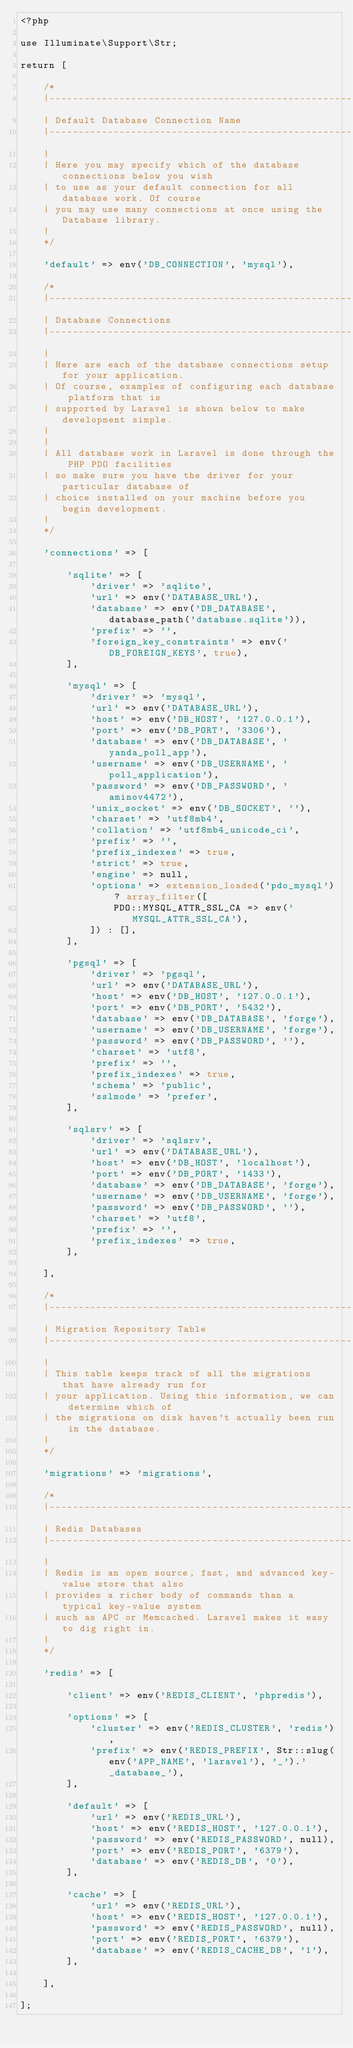Convert code to text. <code><loc_0><loc_0><loc_500><loc_500><_PHP_><?php

use Illuminate\Support\Str;

return [

    /*
    |--------------------------------------------------------------------------
    | Default Database Connection Name
    |--------------------------------------------------------------------------
    |
    | Here you may specify which of the database connections below you wish
    | to use as your default connection for all database work. Of course
    | you may use many connections at once using the Database library.
    |
    */

    'default' => env('DB_CONNECTION', 'mysql'),

    /*
    |--------------------------------------------------------------------------
    | Database Connections
    |--------------------------------------------------------------------------
    |
    | Here are each of the database connections setup for your application.
    | Of course, examples of configuring each database platform that is
    | supported by Laravel is shown below to make development simple.
    |
    |
    | All database work in Laravel is done through the PHP PDO facilities
    | so make sure you have the driver for your particular database of
    | choice installed on your machine before you begin development.
    |
    */

    'connections' => [

        'sqlite' => [
            'driver' => 'sqlite',
            'url' => env('DATABASE_URL'),
            'database' => env('DB_DATABASE', database_path('database.sqlite')),
            'prefix' => '',
            'foreign_key_constraints' => env('DB_FOREIGN_KEYS', true),
        ],

        'mysql' => [
            'driver' => 'mysql',
            'url' => env('DATABASE_URL'),
            'host' => env('DB_HOST', '127.0.0.1'),
            'port' => env('DB_PORT', '3306'),
            'database' => env('DB_DATABASE', 'yanda_poll_app'),
            'username' => env('DB_USERNAME', 'poll_application'),
            'password' => env('DB_PASSWORD', 'aminov4472'),
            'unix_socket' => env('DB_SOCKET', ''),
            'charset' => 'utf8mb4',
            'collation' => 'utf8mb4_unicode_ci',
            'prefix' => '',
            'prefix_indexes' => true,
            'strict' => true,
            'engine' => null,
            'options' => extension_loaded('pdo_mysql') ? array_filter([
                PDO::MYSQL_ATTR_SSL_CA => env('MYSQL_ATTR_SSL_CA'),
            ]) : [],
        ],

        'pgsql' => [
            'driver' => 'pgsql',
            'url' => env('DATABASE_URL'),
            'host' => env('DB_HOST', '127.0.0.1'),
            'port' => env('DB_PORT', '5432'),
            'database' => env('DB_DATABASE', 'forge'),
            'username' => env('DB_USERNAME', 'forge'),
            'password' => env('DB_PASSWORD', ''),
            'charset' => 'utf8',
            'prefix' => '',
            'prefix_indexes' => true,
            'schema' => 'public',
            'sslmode' => 'prefer',
        ],

        'sqlsrv' => [
            'driver' => 'sqlsrv',
            'url' => env('DATABASE_URL'),
            'host' => env('DB_HOST', 'localhost'),
            'port' => env('DB_PORT', '1433'),
            'database' => env('DB_DATABASE', 'forge'),
            'username' => env('DB_USERNAME', 'forge'),
            'password' => env('DB_PASSWORD', ''),
            'charset' => 'utf8',
            'prefix' => '',
            'prefix_indexes' => true,
        ],

    ],

    /*
    |--------------------------------------------------------------------------
    | Migration Repository Table
    |--------------------------------------------------------------------------
    |
    | This table keeps track of all the migrations that have already run for
    | your application. Using this information, we can determine which of
    | the migrations on disk haven't actually been run in the database.
    |
    */

    'migrations' => 'migrations',

    /*
    |--------------------------------------------------------------------------
    | Redis Databases
    |--------------------------------------------------------------------------
    |
    | Redis is an open source, fast, and advanced key-value store that also
    | provides a richer body of commands than a typical key-value system
    | such as APC or Memcached. Laravel makes it easy to dig right in.
    |
    */

    'redis' => [

        'client' => env('REDIS_CLIENT', 'phpredis'),

        'options' => [
            'cluster' => env('REDIS_CLUSTER', 'redis'),
            'prefix' => env('REDIS_PREFIX', Str::slug(env('APP_NAME', 'laravel'), '_').'_database_'),
        ],

        'default' => [
            'url' => env('REDIS_URL'),
            'host' => env('REDIS_HOST', '127.0.0.1'),
            'password' => env('REDIS_PASSWORD', null),
            'port' => env('REDIS_PORT', '6379'),
            'database' => env('REDIS_DB', '0'),
        ],

        'cache' => [
            'url' => env('REDIS_URL'),
            'host' => env('REDIS_HOST', '127.0.0.1'),
            'password' => env('REDIS_PASSWORD', null),
            'port' => env('REDIS_PORT', '6379'),
            'database' => env('REDIS_CACHE_DB', '1'),
        ],

    ],

];
</code> 